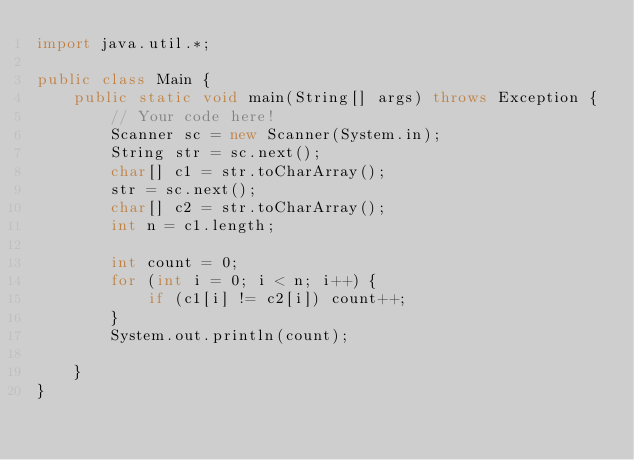Convert code to text. <code><loc_0><loc_0><loc_500><loc_500><_Java_>import java.util.*;

public class Main {
    public static void main(String[] args) throws Exception {
        // Your code here!
        Scanner sc = new Scanner(System.in);
        String str = sc.next();
        char[] c1 = str.toCharArray();
        str = sc.next();
        char[] c2 = str.toCharArray();
        int n = c1.length;
        
        int count = 0;
        for (int i = 0; i < n; i++) {
            if (c1[i] != c2[i]) count++;
        }
        System.out.println(count);
        
    }
}</code> 